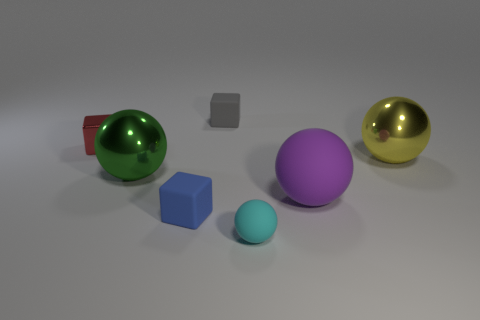Subtract 1 balls. How many balls are left? 3 Add 1 matte spheres. How many objects exist? 8 Subtract all cubes. How many objects are left? 4 Subtract all balls. Subtract all tiny yellow things. How many objects are left? 3 Add 3 large yellow balls. How many large yellow balls are left? 4 Add 4 large brown rubber spheres. How many large brown rubber spheres exist? 4 Subtract 0 purple cylinders. How many objects are left? 7 